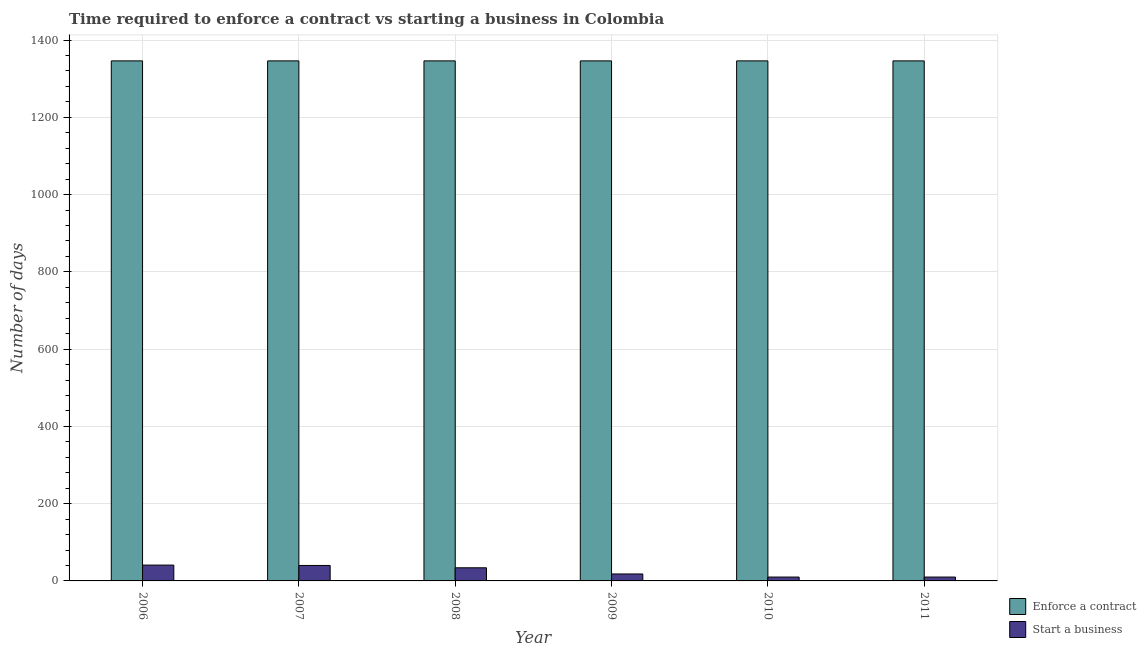How many different coloured bars are there?
Offer a terse response. 2. How many groups of bars are there?
Offer a very short reply. 6. Are the number of bars on each tick of the X-axis equal?
Offer a very short reply. Yes. How many bars are there on the 1st tick from the right?
Keep it short and to the point. 2. In how many cases, is the number of bars for a given year not equal to the number of legend labels?
Make the answer very short. 0. What is the number of days to enforece a contract in 2009?
Give a very brief answer. 1346. Across all years, what is the maximum number of days to enforece a contract?
Your answer should be very brief. 1346. Across all years, what is the minimum number of days to enforece a contract?
Your answer should be very brief. 1346. In which year was the number of days to start a business maximum?
Your answer should be compact. 2006. In which year was the number of days to start a business minimum?
Ensure brevity in your answer.  2010. What is the total number of days to enforece a contract in the graph?
Your response must be concise. 8076. What is the difference between the number of days to start a business in 2008 and that in 2009?
Make the answer very short. 16. In the year 2009, what is the difference between the number of days to start a business and number of days to enforece a contract?
Make the answer very short. 0. In how many years, is the number of days to enforece a contract greater than 160 days?
Your answer should be compact. 6. Is the number of days to start a business in 2008 less than that in 2009?
Give a very brief answer. No. What is the difference between the highest and the lowest number of days to start a business?
Provide a short and direct response. 31. What does the 1st bar from the left in 2008 represents?
Make the answer very short. Enforce a contract. What does the 1st bar from the right in 2011 represents?
Your answer should be very brief. Start a business. Are all the bars in the graph horizontal?
Provide a short and direct response. No. What is the difference between two consecutive major ticks on the Y-axis?
Ensure brevity in your answer.  200. Are the values on the major ticks of Y-axis written in scientific E-notation?
Provide a succinct answer. No. Where does the legend appear in the graph?
Your response must be concise. Bottom right. How many legend labels are there?
Ensure brevity in your answer.  2. How are the legend labels stacked?
Ensure brevity in your answer.  Vertical. What is the title of the graph?
Your response must be concise. Time required to enforce a contract vs starting a business in Colombia. Does "Primary completion rate" appear as one of the legend labels in the graph?
Your answer should be very brief. No. What is the label or title of the X-axis?
Your response must be concise. Year. What is the label or title of the Y-axis?
Your response must be concise. Number of days. What is the Number of days in Enforce a contract in 2006?
Give a very brief answer. 1346. What is the Number of days in Enforce a contract in 2007?
Keep it short and to the point. 1346. What is the Number of days of Enforce a contract in 2008?
Provide a succinct answer. 1346. What is the Number of days of Enforce a contract in 2009?
Give a very brief answer. 1346. What is the Number of days in Enforce a contract in 2010?
Your answer should be very brief. 1346. What is the Number of days in Enforce a contract in 2011?
Ensure brevity in your answer.  1346. What is the Number of days of Start a business in 2011?
Offer a terse response. 10. Across all years, what is the maximum Number of days of Enforce a contract?
Your answer should be compact. 1346. Across all years, what is the minimum Number of days of Enforce a contract?
Provide a succinct answer. 1346. What is the total Number of days in Enforce a contract in the graph?
Make the answer very short. 8076. What is the total Number of days of Start a business in the graph?
Offer a terse response. 153. What is the difference between the Number of days in Enforce a contract in 2006 and that in 2008?
Provide a short and direct response. 0. What is the difference between the Number of days in Enforce a contract in 2006 and that in 2009?
Your response must be concise. 0. What is the difference between the Number of days in Start a business in 2006 and that in 2009?
Offer a terse response. 23. What is the difference between the Number of days of Enforce a contract in 2006 and that in 2011?
Your response must be concise. 0. What is the difference between the Number of days of Enforce a contract in 2007 and that in 2008?
Give a very brief answer. 0. What is the difference between the Number of days of Start a business in 2007 and that in 2008?
Your response must be concise. 6. What is the difference between the Number of days in Start a business in 2007 and that in 2009?
Your answer should be compact. 22. What is the difference between the Number of days of Enforce a contract in 2007 and that in 2010?
Keep it short and to the point. 0. What is the difference between the Number of days in Start a business in 2007 and that in 2011?
Offer a very short reply. 30. What is the difference between the Number of days of Enforce a contract in 2008 and that in 2009?
Your answer should be compact. 0. What is the difference between the Number of days of Start a business in 2008 and that in 2009?
Provide a succinct answer. 16. What is the difference between the Number of days in Enforce a contract in 2008 and that in 2011?
Make the answer very short. 0. What is the difference between the Number of days in Enforce a contract in 2009 and that in 2010?
Your response must be concise. 0. What is the difference between the Number of days in Start a business in 2010 and that in 2011?
Give a very brief answer. 0. What is the difference between the Number of days in Enforce a contract in 2006 and the Number of days in Start a business in 2007?
Offer a terse response. 1306. What is the difference between the Number of days in Enforce a contract in 2006 and the Number of days in Start a business in 2008?
Offer a terse response. 1312. What is the difference between the Number of days of Enforce a contract in 2006 and the Number of days of Start a business in 2009?
Offer a terse response. 1328. What is the difference between the Number of days of Enforce a contract in 2006 and the Number of days of Start a business in 2010?
Offer a terse response. 1336. What is the difference between the Number of days of Enforce a contract in 2006 and the Number of days of Start a business in 2011?
Provide a succinct answer. 1336. What is the difference between the Number of days in Enforce a contract in 2007 and the Number of days in Start a business in 2008?
Offer a terse response. 1312. What is the difference between the Number of days of Enforce a contract in 2007 and the Number of days of Start a business in 2009?
Give a very brief answer. 1328. What is the difference between the Number of days of Enforce a contract in 2007 and the Number of days of Start a business in 2010?
Your answer should be compact. 1336. What is the difference between the Number of days in Enforce a contract in 2007 and the Number of days in Start a business in 2011?
Make the answer very short. 1336. What is the difference between the Number of days in Enforce a contract in 2008 and the Number of days in Start a business in 2009?
Provide a succinct answer. 1328. What is the difference between the Number of days of Enforce a contract in 2008 and the Number of days of Start a business in 2010?
Provide a short and direct response. 1336. What is the difference between the Number of days of Enforce a contract in 2008 and the Number of days of Start a business in 2011?
Give a very brief answer. 1336. What is the difference between the Number of days of Enforce a contract in 2009 and the Number of days of Start a business in 2010?
Your response must be concise. 1336. What is the difference between the Number of days of Enforce a contract in 2009 and the Number of days of Start a business in 2011?
Provide a short and direct response. 1336. What is the difference between the Number of days of Enforce a contract in 2010 and the Number of days of Start a business in 2011?
Your answer should be compact. 1336. What is the average Number of days of Enforce a contract per year?
Give a very brief answer. 1346. What is the average Number of days in Start a business per year?
Offer a very short reply. 25.5. In the year 2006, what is the difference between the Number of days of Enforce a contract and Number of days of Start a business?
Keep it short and to the point. 1305. In the year 2007, what is the difference between the Number of days of Enforce a contract and Number of days of Start a business?
Give a very brief answer. 1306. In the year 2008, what is the difference between the Number of days in Enforce a contract and Number of days in Start a business?
Provide a succinct answer. 1312. In the year 2009, what is the difference between the Number of days of Enforce a contract and Number of days of Start a business?
Your response must be concise. 1328. In the year 2010, what is the difference between the Number of days in Enforce a contract and Number of days in Start a business?
Ensure brevity in your answer.  1336. In the year 2011, what is the difference between the Number of days in Enforce a contract and Number of days in Start a business?
Provide a succinct answer. 1336. What is the ratio of the Number of days of Start a business in 2006 to that in 2007?
Your response must be concise. 1.02. What is the ratio of the Number of days in Start a business in 2006 to that in 2008?
Provide a short and direct response. 1.21. What is the ratio of the Number of days in Start a business in 2006 to that in 2009?
Offer a very short reply. 2.28. What is the ratio of the Number of days in Enforce a contract in 2006 to that in 2010?
Offer a terse response. 1. What is the ratio of the Number of days in Start a business in 2006 to that in 2010?
Ensure brevity in your answer.  4.1. What is the ratio of the Number of days in Enforce a contract in 2007 to that in 2008?
Your response must be concise. 1. What is the ratio of the Number of days of Start a business in 2007 to that in 2008?
Give a very brief answer. 1.18. What is the ratio of the Number of days in Enforce a contract in 2007 to that in 2009?
Give a very brief answer. 1. What is the ratio of the Number of days of Start a business in 2007 to that in 2009?
Give a very brief answer. 2.22. What is the ratio of the Number of days of Enforce a contract in 2007 to that in 2010?
Your response must be concise. 1. What is the ratio of the Number of days of Start a business in 2007 to that in 2010?
Your answer should be compact. 4. What is the ratio of the Number of days of Enforce a contract in 2007 to that in 2011?
Offer a terse response. 1. What is the ratio of the Number of days in Start a business in 2007 to that in 2011?
Make the answer very short. 4. What is the ratio of the Number of days of Enforce a contract in 2008 to that in 2009?
Offer a terse response. 1. What is the ratio of the Number of days of Start a business in 2008 to that in 2009?
Give a very brief answer. 1.89. What is the ratio of the Number of days of Enforce a contract in 2008 to that in 2010?
Make the answer very short. 1. What is the ratio of the Number of days in Start a business in 2008 to that in 2011?
Provide a succinct answer. 3.4. What is the ratio of the Number of days of Enforce a contract in 2009 to that in 2010?
Provide a short and direct response. 1. What is the ratio of the Number of days in Enforce a contract in 2009 to that in 2011?
Provide a short and direct response. 1. What is the ratio of the Number of days in Enforce a contract in 2010 to that in 2011?
Make the answer very short. 1. What is the difference between the highest and the second highest Number of days of Enforce a contract?
Provide a succinct answer. 0. What is the difference between the highest and the second highest Number of days in Start a business?
Your answer should be compact. 1. What is the difference between the highest and the lowest Number of days in Start a business?
Provide a short and direct response. 31. 